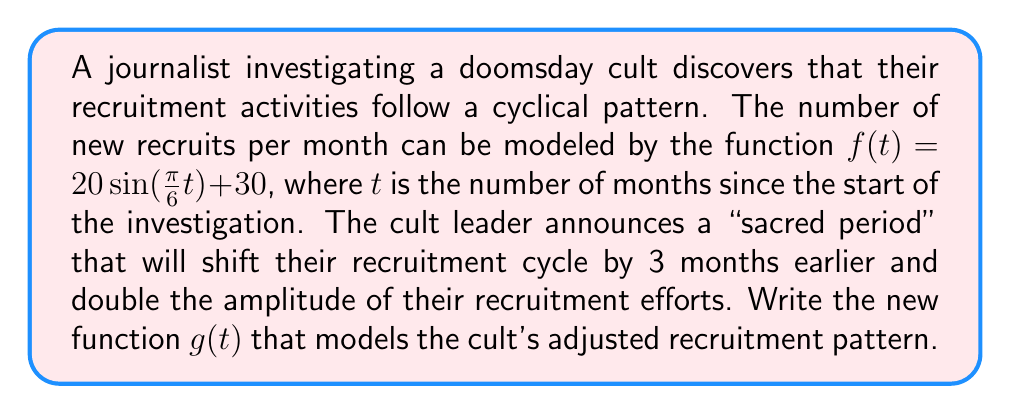Teach me how to tackle this problem. To transform the original function $f(t) = 20\sin(\frac{\pi}{6}t) + 30$ into the new function $g(t)$, we need to apply two transformations:

1. Shift the function 3 months earlier:
   This is a horizontal shift to the right by 3 units. We replace $t$ with $(t+3)$:
   $$f_1(t) = 20\sin(\frac{\pi}{6}(t+3)) + 30$$

2. Double the amplitude:
   The amplitude is represented by the coefficient of the sine function. We multiply this by 2:
   $$g(t) = 2 \cdot 20\sin(\frac{\pi}{6}(t+3)) + 30$$

Simplifying:
$$g(t) = 40\sin(\frac{\pi}{6}(t+3)) + 30$$

This new function $g(t)$ represents the cult's adjusted recruitment pattern with an earlier cycle and doubled amplitude.
Answer: $g(t) = 40\sin(\frac{\pi}{6}(t+3)) + 30$ 